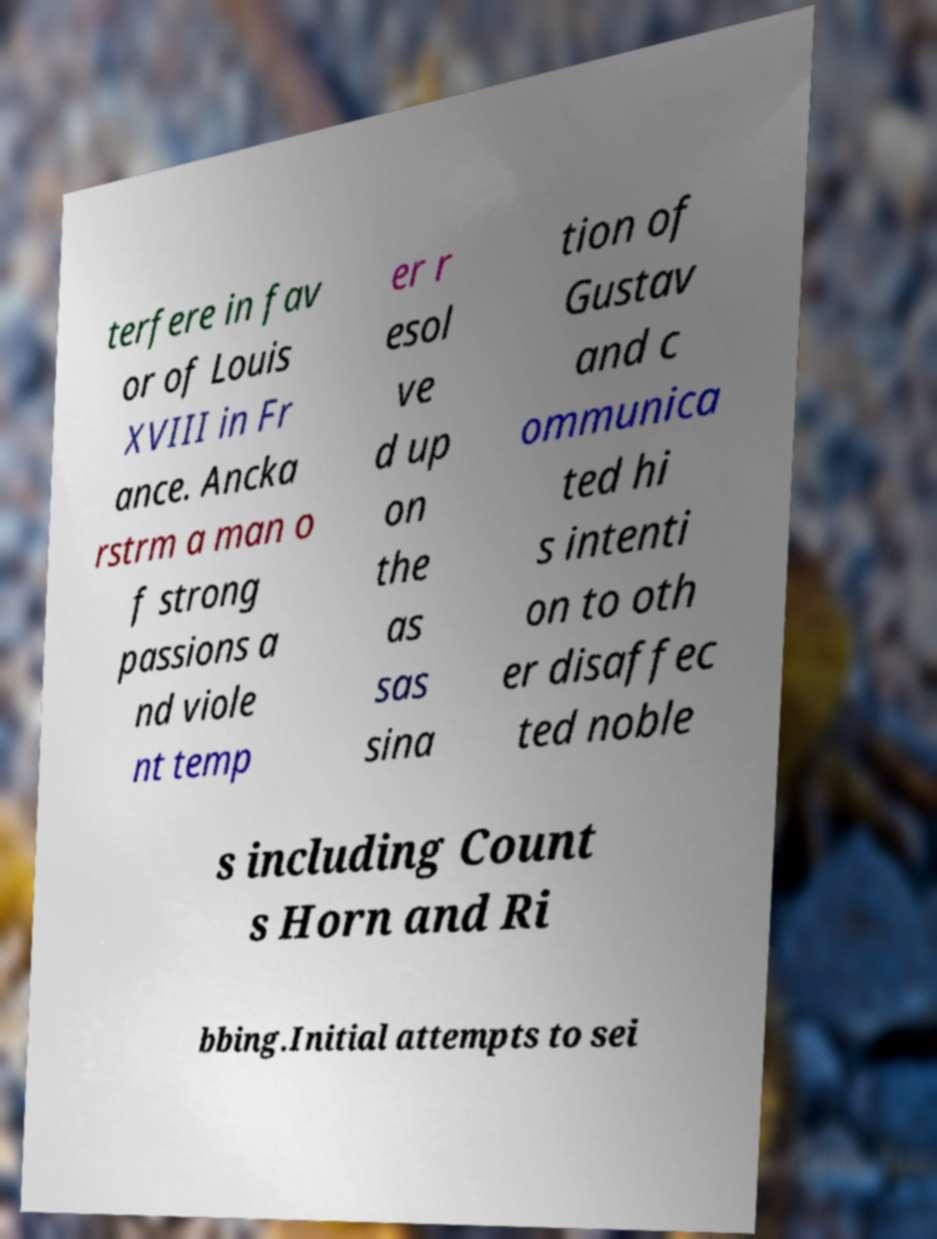Can you read and provide the text displayed in the image?This photo seems to have some interesting text. Can you extract and type it out for me? terfere in fav or of Louis XVIII in Fr ance. Ancka rstrm a man o f strong passions a nd viole nt temp er r esol ve d up on the as sas sina tion of Gustav and c ommunica ted hi s intenti on to oth er disaffec ted noble s including Count s Horn and Ri bbing.Initial attempts to sei 